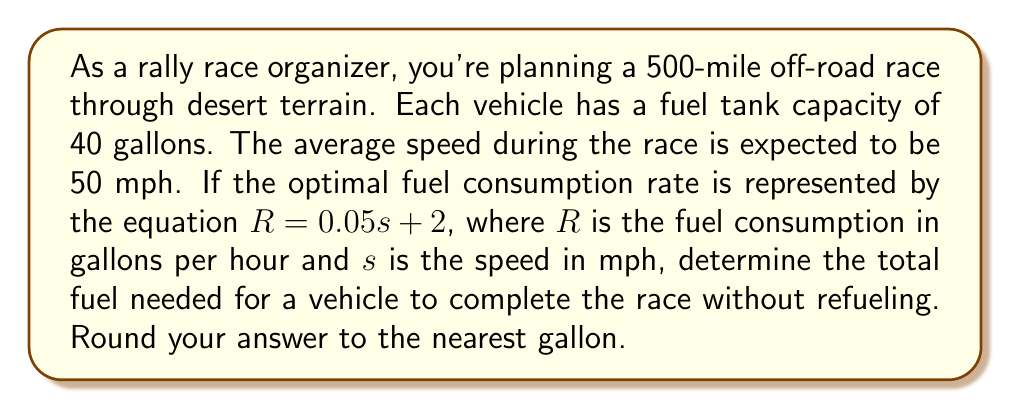Provide a solution to this math problem. Let's approach this problem step-by-step:

1) First, we need to find the total time of the race:
   $\text{Time} = \frac{\text{Distance}}{\text{Speed}} = \frac{500 \text{ miles}}{50 \text{ mph}} = 10 \text{ hours}$

2) Now, we need to calculate the fuel consumption rate using the given equation:
   $R = 0.05s + 2$
   $R = 0.05(50) + 2 = 2.5 + 2 = 4.5 \text{ gallons per hour}$

3) To find the total fuel needed, we multiply the fuel consumption rate by the total time:
   $\text{Total Fuel} = R \times \text{Time} = 4.5 \text{ gal/hr} \times 10 \text{ hr} = 45 \text{ gallons}$

4) However, we need to check if this exceeds the fuel tank capacity:
   The fuel tank capacity is 40 gallons, which is less than the 45 gallons required.

5) Therefore, the vehicle cannot complete the race without refueling. The optimal fuel consumption would be to use the entire tank capacity.
Answer: The optimal fuel consumption for a vehicle to complete the race without refueling is 40 gallons, which is the maximum tank capacity. 